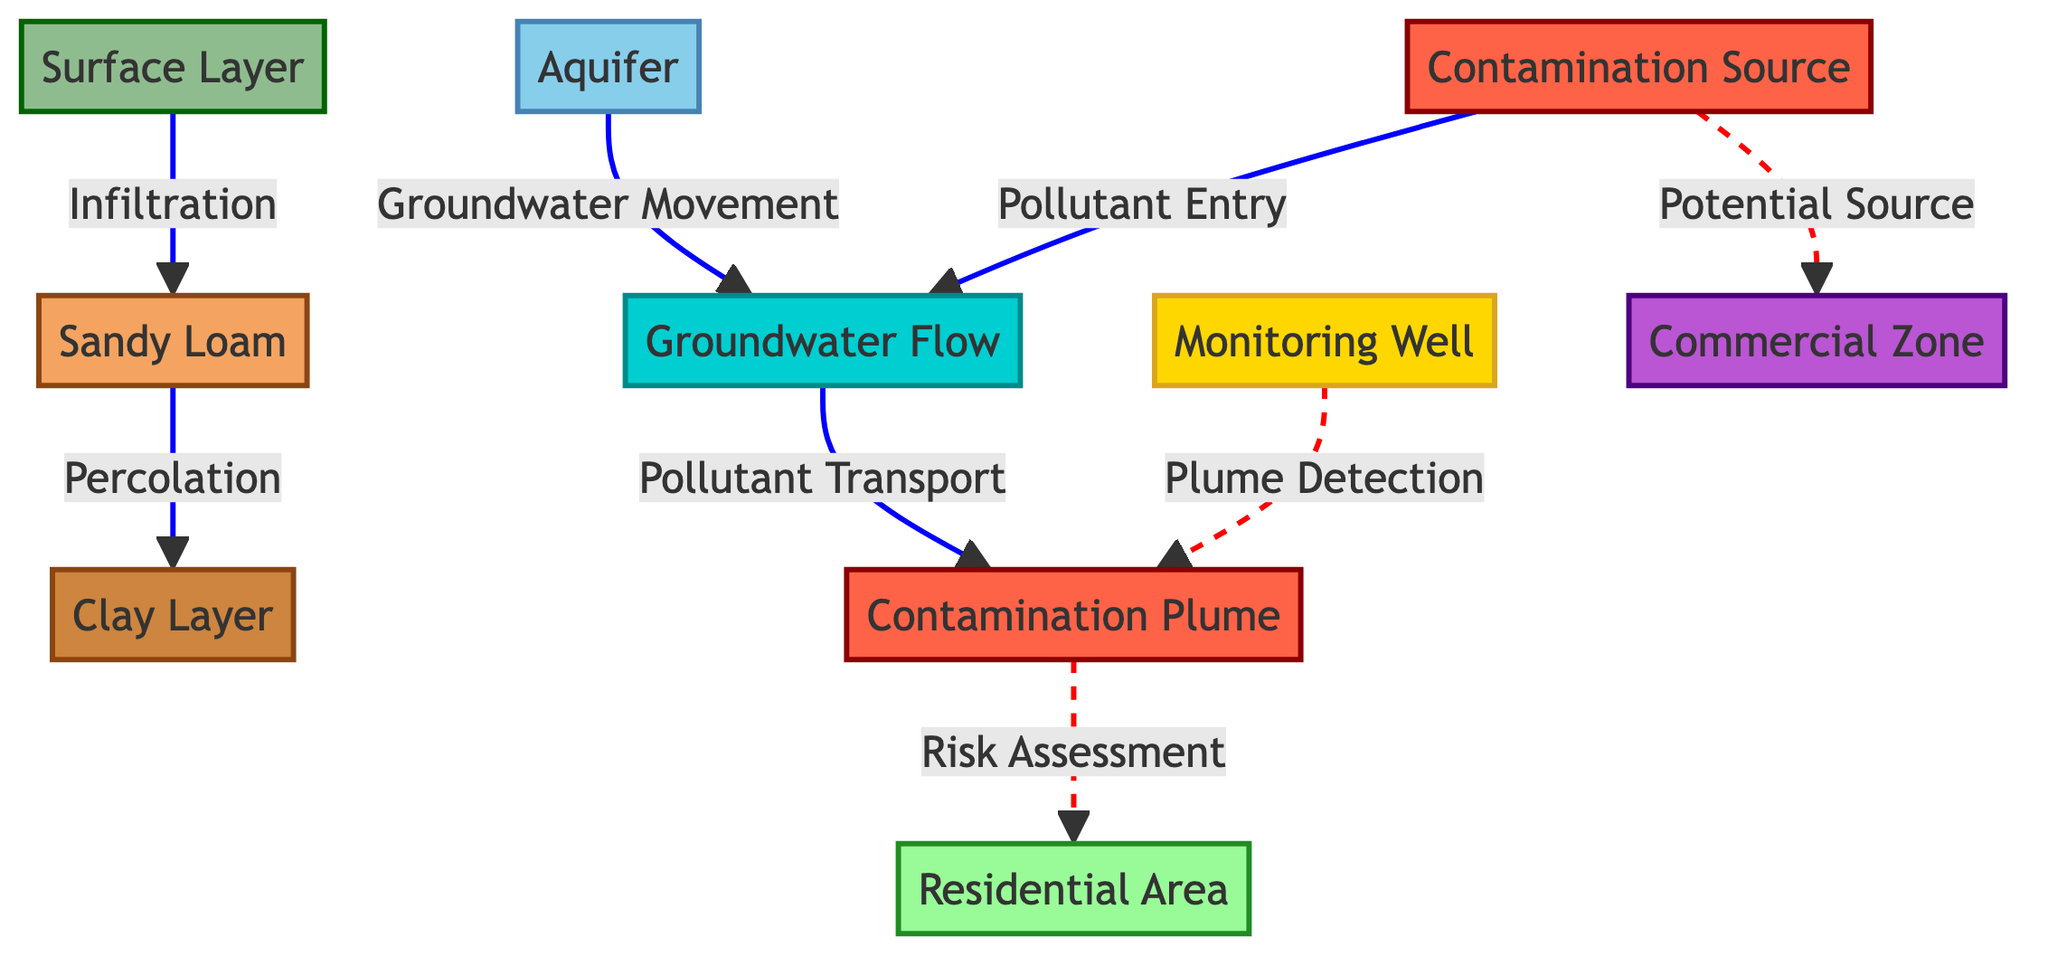What is the top layer shown in the diagram? The diagram clearly labels the top layer as the "Surface Layer," so this is the answer.
Answer: Surface Layer How many geological layers are displayed in the diagram? The diagram has four distinct geological layers: Surface Layer, Sandy Loam, Clay Layer, and Aquifer. Therefore, the total count of geological layers is four.
Answer: 4 What type of flow is occurring from the aquifer to the groundwater flow? The connection indicates that "Groundwater Movement" occurs from the Aquifer to the Groundwater Flow, according to the arrows in the diagram.
Answer: Groundwater Movement What represents the contamination source in this diagram? The diagram designates the node labeled "Contamination Source" as the source of pollutants, marked in red.
Answer: Contamination Source Which area is affected by the contamination plume based on the diagram? The diagram shows that the "Residential Area" is directly linked to the "Contamination Plume" through a dashed arrow indicating a relationship.
Answer: Residential Area What type of zoning is indicated in the diagram near potential pollution sources? The diagram highlights a "Commercial Zone" potentially linking it to the contamination sources, showing it as a notable area of concern.
Answer: Commercial Zone How does pollution enter the groundwater flow? The diagram illustrates "Pollutant Entry" from the "Contamination Source" directly into the "Groundwater Flow," showing how contaminants are introduced.
Answer: Pollutant Entry What is being detected by the monitoring well according to the diagram? The dashed line leading from the "Monitoring Well" points to the "Contamination Plume," indicating that it is detecting this plume.
Answer: Plume Detection What actions follow after detecting the contamination plume as per the diagram? Once the "Contamination Plume" is detected, the next action indicated is "Risk Assessment" for the "Residential Area," detailing the process of evaluating risks.
Answer: Risk Assessment 